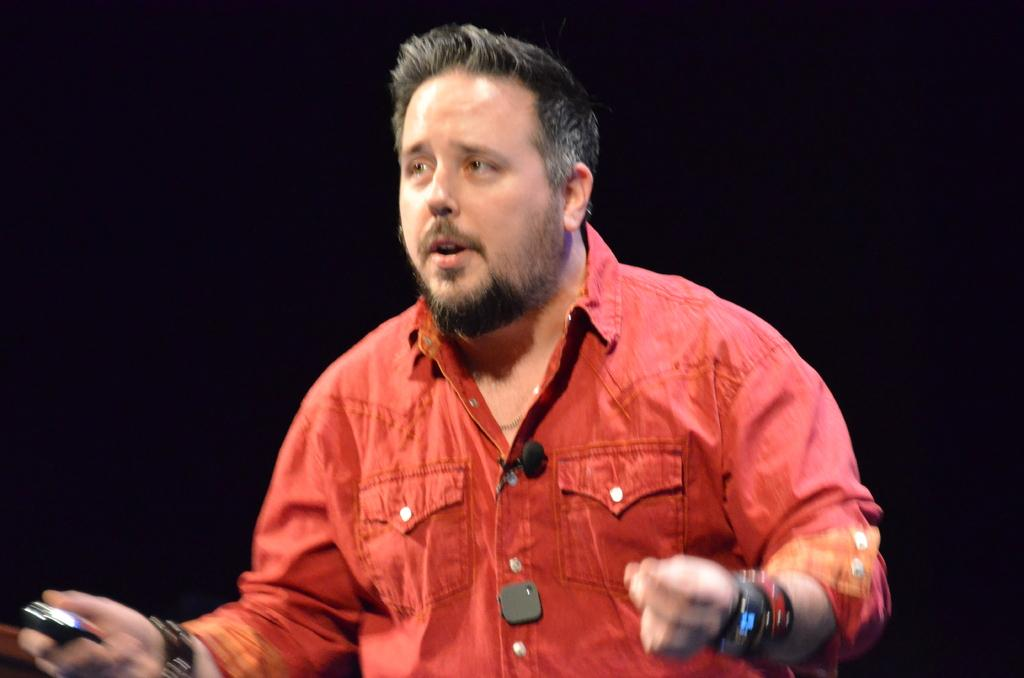What is the main subject of the image? The main subject of the image is a man. What is the man wearing? The man is wearing a red shirt. What is the man holding in the image? The man is holding an object. What is the man doing in the image? The man appears to be talking. What can be observed about the background of the image? The background of the image is dark. What type of quince is the man holding in the image? There is no quince present in the image; the man is holding an unspecified object. Can you tell me how many kittens are sitting on the man's shoulders in the image? There are no kittens present in the image; the man is alone in the image. 